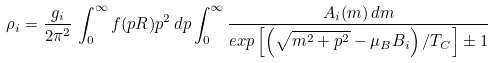<formula> <loc_0><loc_0><loc_500><loc_500>\rho _ { i } = \frac { g _ { i } } { 2 \pi ^ { 2 } } \, \int _ { 0 } ^ { \infty } f ( p R ) p ^ { 2 } \, d p \int _ { 0 } ^ { \infty } \frac { A _ { i } ( m ) \, d m } { e x p \left [ \left ( \sqrt { m ^ { 2 } + p ^ { 2 } } - \mu _ { B } B _ { i } \right ) / T _ { C } \right ] \pm 1 }</formula> 